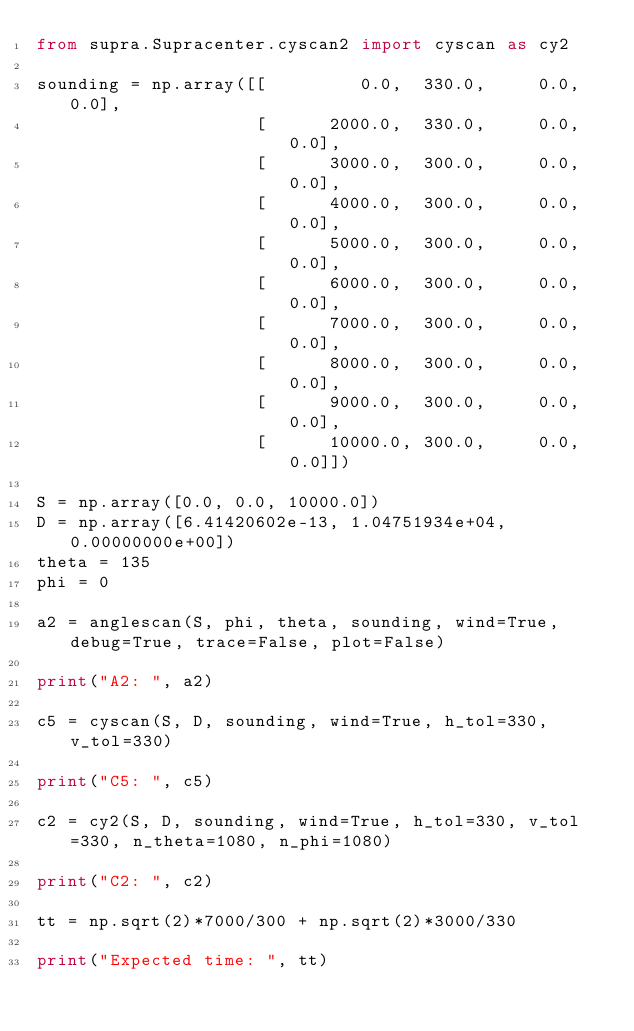<code> <loc_0><loc_0><loc_500><loc_500><_Python_>from supra.Supracenter.cyscan2 import cyscan as cy2

sounding = np.array([[		   0.0,  330.0,  	0.0, 0.0], 
					 [		2000.0,  330.0,  	0.0, 0.0], 
					 [		3000.0,  300.0,  	0.0, 0.0], 
					 [		4000.0,  300.0,  	0.0, 0.0], 
					 [		5000.0,  300.0,  	0.0, 0.0], 
					 [		6000.0,  300.0,  	0.0, 0.0], 
					 [		7000.0,  300.0,  	0.0, 0.0], 
					 [		8000.0,  300.0, 	0.0, 0.0], 
					 [		9000.0,  300.0, 	0.0, 0.0], 
					 [      10000.0, 300.0,  	0.0, 0.0]])

S = np.array([0.0, 0.0, 10000.0])
D = np.array([6.41420602e-13, 1.04751934e+04, 0.00000000e+00])
theta = 135
phi = 0

a2 = anglescan(S, phi, theta, sounding, wind=True, debug=True, trace=False, plot=False)

print("A2: ", a2)

c5 = cyscan(S, D, sounding, wind=True, h_tol=330, v_tol=330)

print("C5: ", c5)

c2 = cy2(S, D, sounding, wind=True, h_tol=330, v_tol=330, n_theta=1080, n_phi=1080)

print("C2: ", c2)

tt = np.sqrt(2)*7000/300 + np.sqrt(2)*3000/330

print("Expected time: ", tt)
</code> 